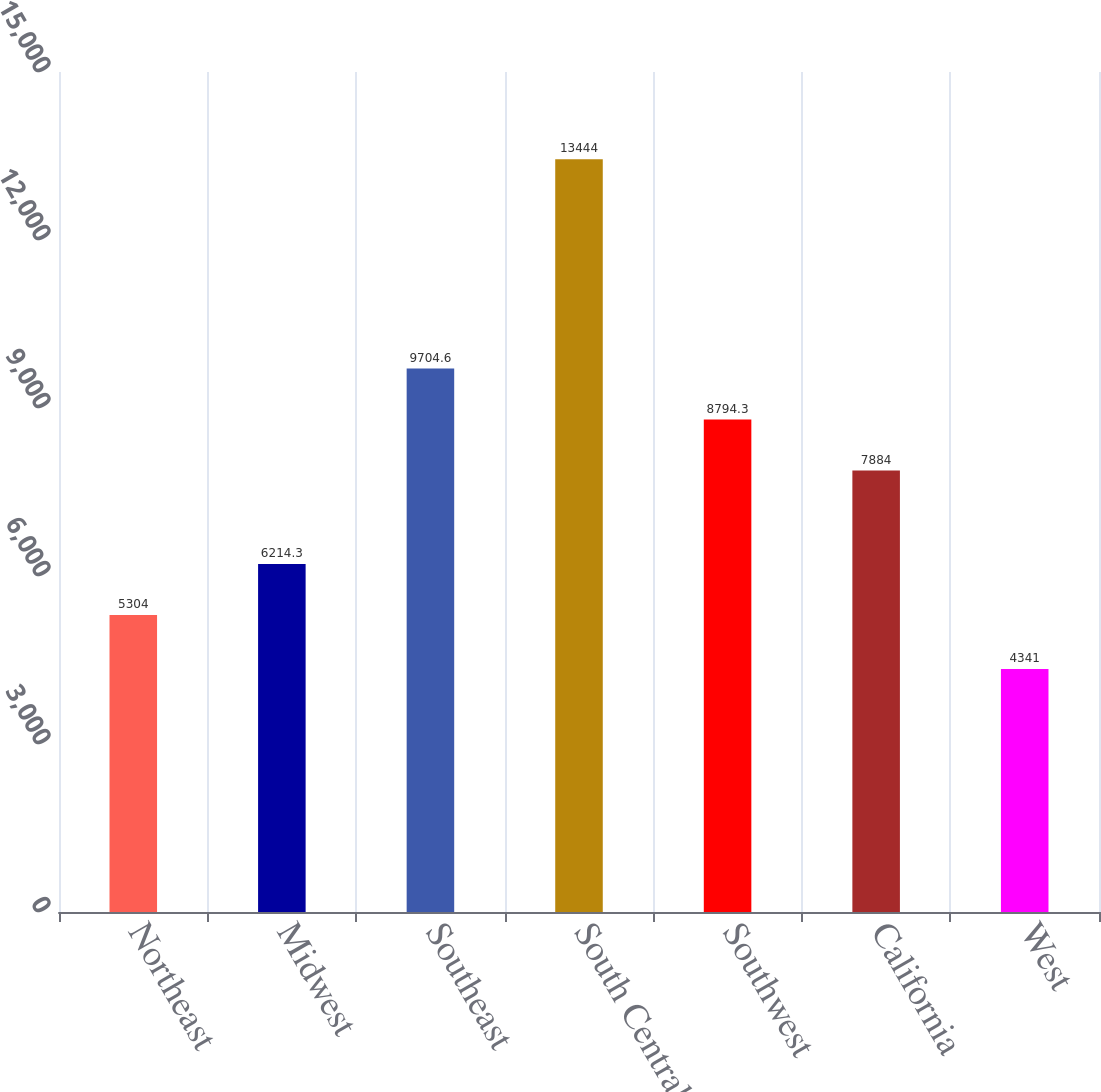<chart> <loc_0><loc_0><loc_500><loc_500><bar_chart><fcel>Northeast<fcel>Midwest<fcel>Southeast<fcel>South Central<fcel>Southwest<fcel>California<fcel>West<nl><fcel>5304<fcel>6214.3<fcel>9704.6<fcel>13444<fcel>8794.3<fcel>7884<fcel>4341<nl></chart> 